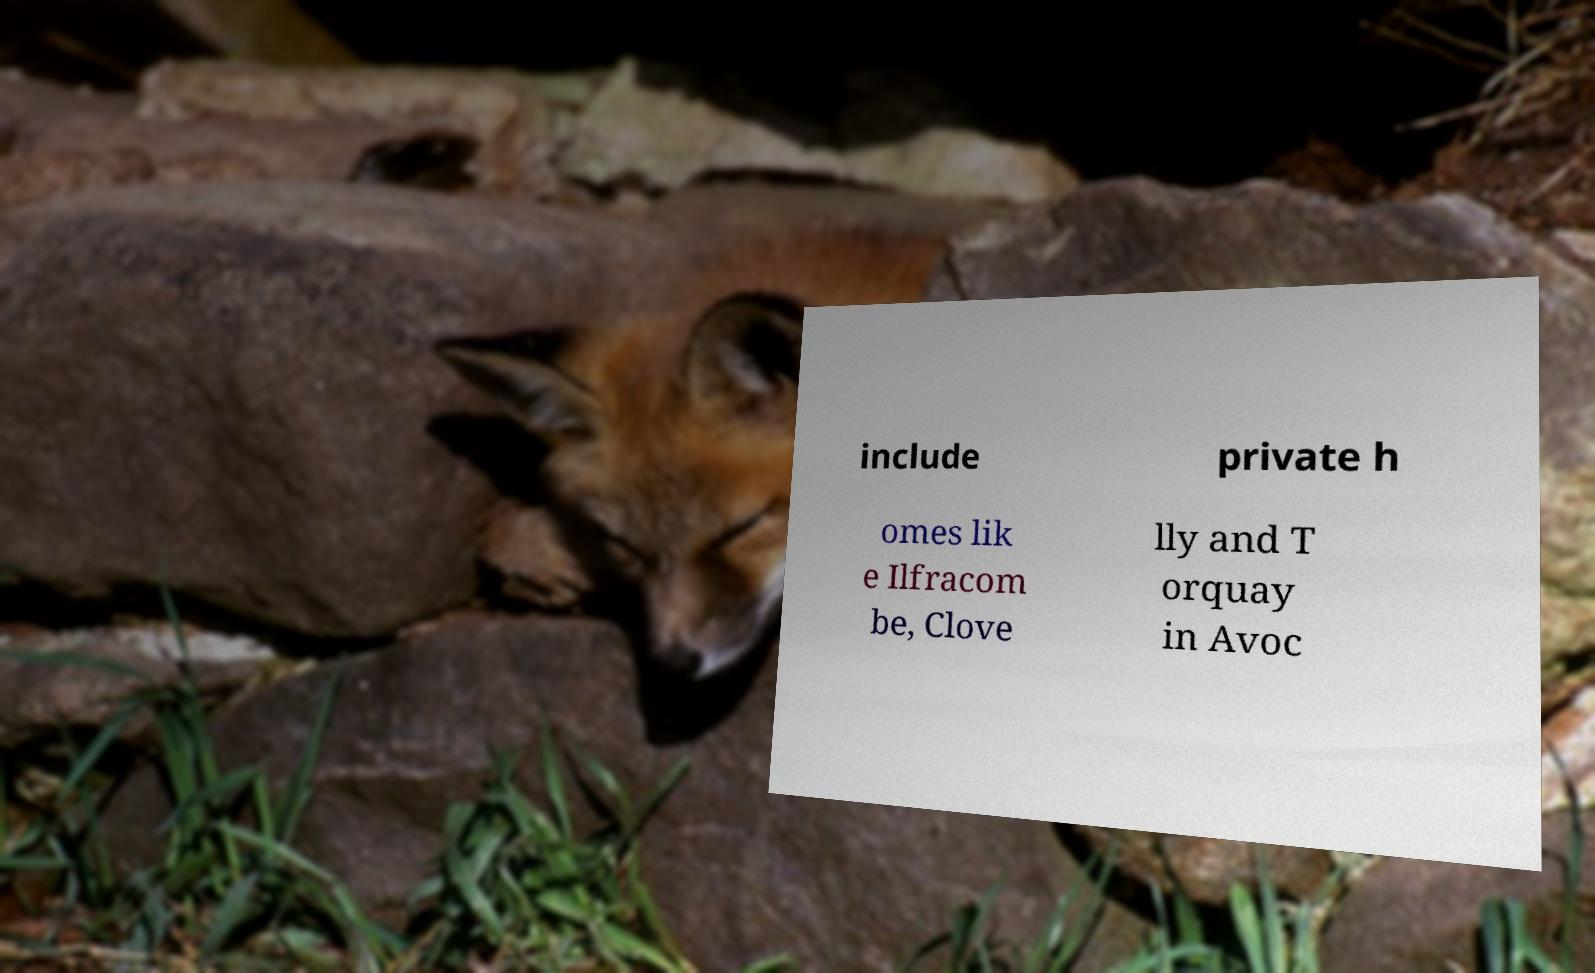Please identify and transcribe the text found in this image. include private h omes lik e Ilfracom be, Clove lly and T orquay in Avoc 